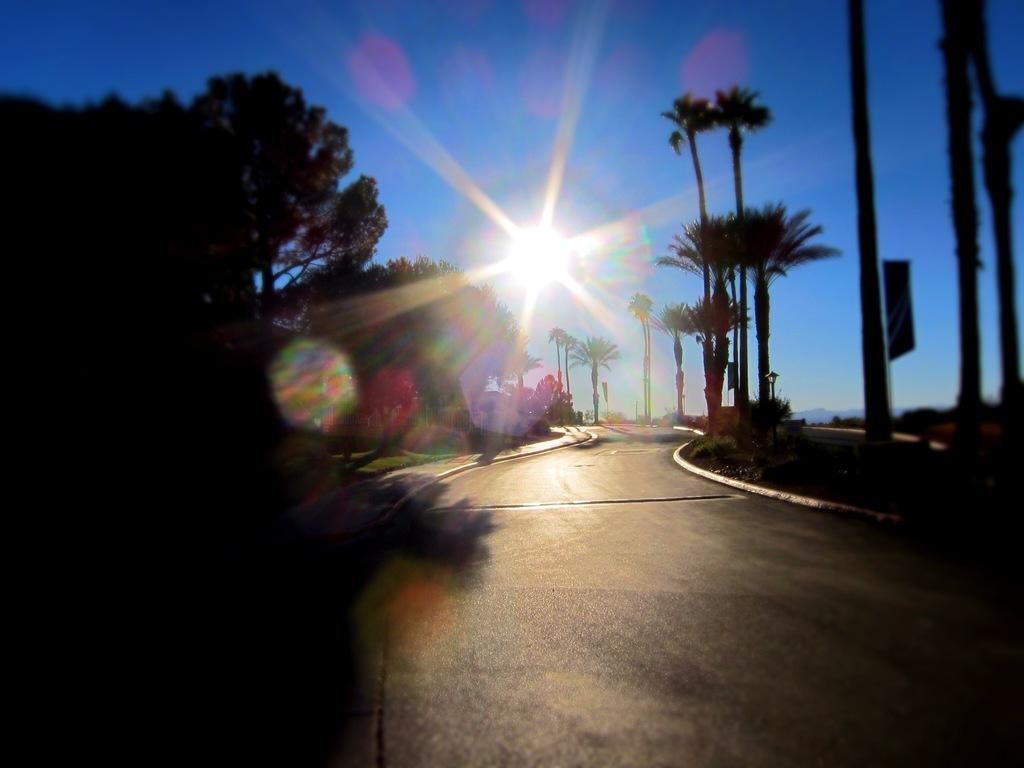What type of terrain is visible in the image? The ground is visible in the image, and there is grass visible as well. What type of vegetation can be seen in the image? There are trees and plants in the image. What structures are present in the image? There are poles in the image. What is visible in the sky in the image? The sky is visible in the image, and the sun is observable. Can you tell me how many roads are visible in the image? There are no roads visible in the image. What type of existence does the seashore have in the image? There is no seashore present in the image. 